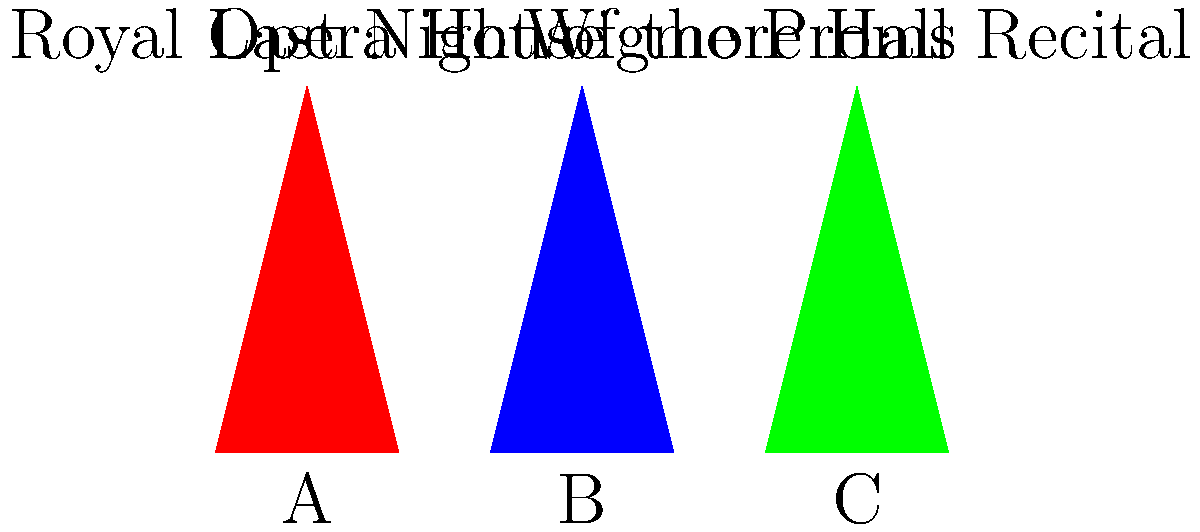Match Lesley Garrett's iconic outfits (represented by the colored triangles A, B, and C) to her specific performances. Which outfit corresponds to her appearance at the Last Night of the Proms? To answer this question, we need to consider Lesley Garrett's typical style choices for different performance venues:

1. Royal Opera House (A): For grand opera performances, Lesley often wears elaborate, floor-length gowns. The red triangle represents this type of outfit.

2. Last Night of the Proms (B): This event is known for its patriotic atmosphere. Lesley typically wears something eye-catching and often in blue, symbolizing the British flag colors. The blue triangle represents this outfit.

3. Wigmore Hall Recital (C): For more intimate recitals, Lesley often opts for elegant but slightly less formal attire. The green triangle represents this type of outfit.

Given these associations, we can conclude that the blue triangle (B) corresponds to Lesley Garrett's appearance at the Last Night of the Proms.
Answer: B 